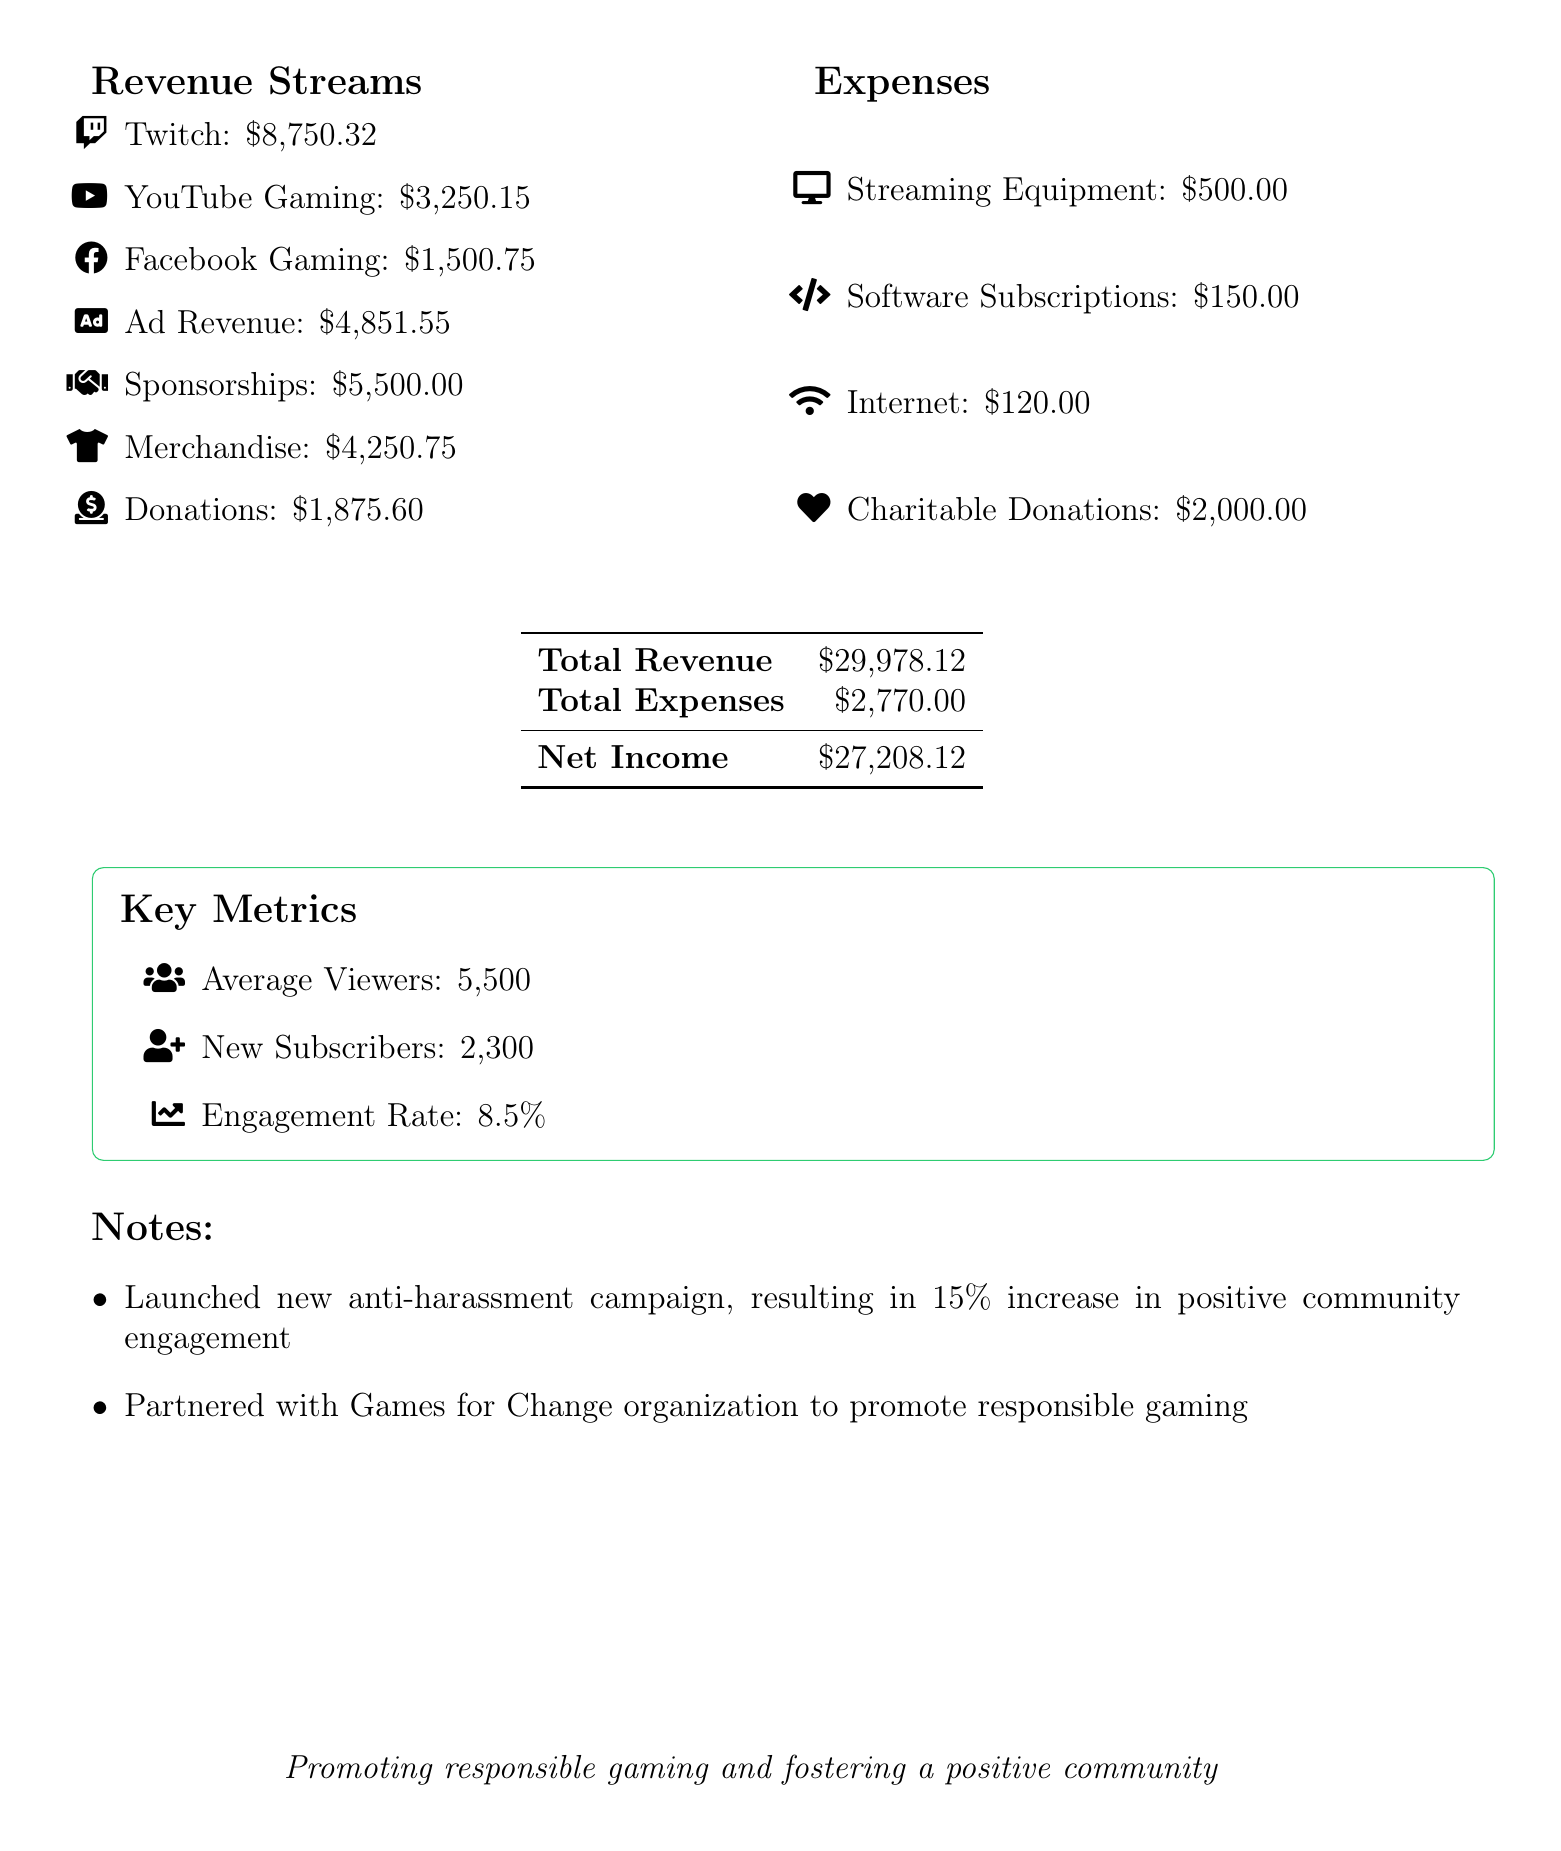what is the total revenue? The total revenue is the sum of all revenue sources in the document, which amounts to $29,978.12.
Answer: $29,978.12 what is the net income? The net income is calculated by subtracting total expenses from total revenue, resulting in $27,208.12.
Answer: $27,208.12 how much did the Twitch revenue amount to? According to the report, Twitch revenue totaled $8,750.32.
Answer: $8,750.32 what is the engagement rate? The engagement rate is presented as a percentage, which is 8.5%.
Answer: 8.5% how much was spent on charitable donations? The expenses related to charitable donations were reported as $2,000.00.
Answer: $2,000.00 how many new subscribers were gained? The document states that the number of new subscribers gained was 2,300.
Answer: 2,300 what initiative led to a 15% increase in community engagement? The notes mention the launch of a new anti-harassment campaign.
Answer: anti-harassment campaign which organizations were mentioned in the sponsorship section? The sponsorship section lists Razer and HyperX.
Answer: Razer, HyperX what was the income from merchandise sales? The report specifies that merchandise sales generated $4,250.75.
Answer: $4,250.75 what is the average number of viewers? The average number of viewers is stated as 5,500.
Answer: 5,500 